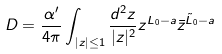<formula> <loc_0><loc_0><loc_500><loc_500>D = \frac { \alpha ^ { \prime } } { 4 \pi } \int _ { | z | \leq 1 } \frac { d ^ { 2 } z } { | z | ^ { 2 } } z ^ { L _ { 0 } - a } \bar { z } ^ { \tilde { L } _ { 0 } - a }</formula> 